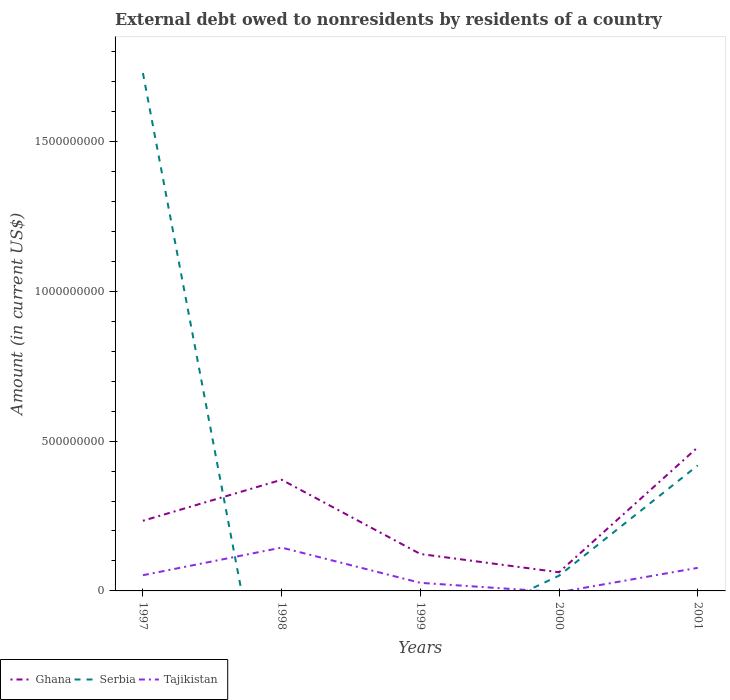How many different coloured lines are there?
Offer a very short reply. 3. Is the number of lines equal to the number of legend labels?
Ensure brevity in your answer.  No. Across all years, what is the maximum external debt owed by residents in Ghana?
Keep it short and to the point. 6.23e+07. What is the total external debt owed by residents in Serbia in the graph?
Keep it short and to the point. 1.31e+09. What is the difference between the highest and the second highest external debt owed by residents in Ghana?
Make the answer very short. 4.17e+08. What is the difference between the highest and the lowest external debt owed by residents in Tajikistan?
Your answer should be very brief. 2. Is the external debt owed by residents in Ghana strictly greater than the external debt owed by residents in Tajikistan over the years?
Your answer should be compact. No. How many years are there in the graph?
Your answer should be very brief. 5. What is the title of the graph?
Your response must be concise. External debt owed to nonresidents by residents of a country. Does "Burkina Faso" appear as one of the legend labels in the graph?
Give a very brief answer. No. What is the label or title of the Y-axis?
Your answer should be compact. Amount (in current US$). What is the Amount (in current US$) of Ghana in 1997?
Provide a short and direct response. 2.34e+08. What is the Amount (in current US$) of Serbia in 1997?
Provide a short and direct response. 1.73e+09. What is the Amount (in current US$) in Tajikistan in 1997?
Your answer should be very brief. 5.24e+07. What is the Amount (in current US$) in Ghana in 1998?
Offer a very short reply. 3.71e+08. What is the Amount (in current US$) in Tajikistan in 1998?
Ensure brevity in your answer.  1.45e+08. What is the Amount (in current US$) of Ghana in 1999?
Make the answer very short. 1.23e+08. What is the Amount (in current US$) in Tajikistan in 1999?
Offer a terse response. 2.70e+07. What is the Amount (in current US$) in Ghana in 2000?
Your answer should be compact. 6.23e+07. What is the Amount (in current US$) of Serbia in 2000?
Provide a succinct answer. 5.08e+07. What is the Amount (in current US$) of Tajikistan in 2000?
Your response must be concise. 0. What is the Amount (in current US$) in Ghana in 2001?
Provide a succinct answer. 4.79e+08. What is the Amount (in current US$) in Serbia in 2001?
Make the answer very short. 4.19e+08. What is the Amount (in current US$) in Tajikistan in 2001?
Provide a short and direct response. 7.70e+07. Across all years, what is the maximum Amount (in current US$) of Ghana?
Your answer should be compact. 4.79e+08. Across all years, what is the maximum Amount (in current US$) in Serbia?
Offer a very short reply. 1.73e+09. Across all years, what is the maximum Amount (in current US$) of Tajikistan?
Your response must be concise. 1.45e+08. Across all years, what is the minimum Amount (in current US$) in Ghana?
Give a very brief answer. 6.23e+07. Across all years, what is the minimum Amount (in current US$) in Serbia?
Give a very brief answer. 0. Across all years, what is the minimum Amount (in current US$) of Tajikistan?
Offer a very short reply. 0. What is the total Amount (in current US$) of Ghana in the graph?
Provide a succinct answer. 1.27e+09. What is the total Amount (in current US$) in Serbia in the graph?
Make the answer very short. 2.20e+09. What is the total Amount (in current US$) of Tajikistan in the graph?
Offer a terse response. 3.01e+08. What is the difference between the Amount (in current US$) of Ghana in 1997 and that in 1998?
Provide a short and direct response. -1.37e+08. What is the difference between the Amount (in current US$) in Tajikistan in 1997 and that in 1998?
Give a very brief answer. -9.22e+07. What is the difference between the Amount (in current US$) in Ghana in 1997 and that in 1999?
Your answer should be very brief. 1.11e+08. What is the difference between the Amount (in current US$) of Tajikistan in 1997 and that in 1999?
Keep it short and to the point. 2.54e+07. What is the difference between the Amount (in current US$) of Ghana in 1997 and that in 2000?
Provide a short and direct response. 1.72e+08. What is the difference between the Amount (in current US$) in Serbia in 1997 and that in 2000?
Ensure brevity in your answer.  1.68e+09. What is the difference between the Amount (in current US$) in Ghana in 1997 and that in 2001?
Keep it short and to the point. -2.45e+08. What is the difference between the Amount (in current US$) in Serbia in 1997 and that in 2001?
Give a very brief answer. 1.31e+09. What is the difference between the Amount (in current US$) in Tajikistan in 1997 and that in 2001?
Provide a short and direct response. -2.46e+07. What is the difference between the Amount (in current US$) of Ghana in 1998 and that in 1999?
Ensure brevity in your answer.  2.48e+08. What is the difference between the Amount (in current US$) in Tajikistan in 1998 and that in 1999?
Your answer should be compact. 1.18e+08. What is the difference between the Amount (in current US$) in Ghana in 1998 and that in 2000?
Provide a succinct answer. 3.09e+08. What is the difference between the Amount (in current US$) of Ghana in 1998 and that in 2001?
Keep it short and to the point. -1.08e+08. What is the difference between the Amount (in current US$) of Tajikistan in 1998 and that in 2001?
Your response must be concise. 6.76e+07. What is the difference between the Amount (in current US$) in Ghana in 1999 and that in 2000?
Ensure brevity in your answer.  6.10e+07. What is the difference between the Amount (in current US$) in Ghana in 1999 and that in 2001?
Your answer should be compact. -3.56e+08. What is the difference between the Amount (in current US$) in Tajikistan in 1999 and that in 2001?
Your answer should be very brief. -5.00e+07. What is the difference between the Amount (in current US$) in Ghana in 2000 and that in 2001?
Your answer should be very brief. -4.17e+08. What is the difference between the Amount (in current US$) of Serbia in 2000 and that in 2001?
Ensure brevity in your answer.  -3.68e+08. What is the difference between the Amount (in current US$) in Ghana in 1997 and the Amount (in current US$) in Tajikistan in 1998?
Make the answer very short. 8.95e+07. What is the difference between the Amount (in current US$) of Serbia in 1997 and the Amount (in current US$) of Tajikistan in 1998?
Your answer should be compact. 1.58e+09. What is the difference between the Amount (in current US$) in Ghana in 1997 and the Amount (in current US$) in Tajikistan in 1999?
Make the answer very short. 2.07e+08. What is the difference between the Amount (in current US$) in Serbia in 1997 and the Amount (in current US$) in Tajikistan in 1999?
Make the answer very short. 1.70e+09. What is the difference between the Amount (in current US$) of Ghana in 1997 and the Amount (in current US$) of Serbia in 2000?
Make the answer very short. 1.83e+08. What is the difference between the Amount (in current US$) of Ghana in 1997 and the Amount (in current US$) of Serbia in 2001?
Offer a very short reply. -1.85e+08. What is the difference between the Amount (in current US$) in Ghana in 1997 and the Amount (in current US$) in Tajikistan in 2001?
Make the answer very short. 1.57e+08. What is the difference between the Amount (in current US$) of Serbia in 1997 and the Amount (in current US$) of Tajikistan in 2001?
Offer a very short reply. 1.65e+09. What is the difference between the Amount (in current US$) of Ghana in 1998 and the Amount (in current US$) of Tajikistan in 1999?
Give a very brief answer. 3.44e+08. What is the difference between the Amount (in current US$) in Ghana in 1998 and the Amount (in current US$) in Serbia in 2000?
Make the answer very short. 3.20e+08. What is the difference between the Amount (in current US$) in Ghana in 1998 and the Amount (in current US$) in Serbia in 2001?
Offer a very short reply. -4.78e+07. What is the difference between the Amount (in current US$) of Ghana in 1998 and the Amount (in current US$) of Tajikistan in 2001?
Offer a very short reply. 2.94e+08. What is the difference between the Amount (in current US$) in Ghana in 1999 and the Amount (in current US$) in Serbia in 2000?
Your answer should be compact. 7.25e+07. What is the difference between the Amount (in current US$) of Ghana in 1999 and the Amount (in current US$) of Serbia in 2001?
Keep it short and to the point. -2.96e+08. What is the difference between the Amount (in current US$) in Ghana in 1999 and the Amount (in current US$) in Tajikistan in 2001?
Your answer should be compact. 4.63e+07. What is the difference between the Amount (in current US$) in Ghana in 2000 and the Amount (in current US$) in Serbia in 2001?
Provide a short and direct response. -3.57e+08. What is the difference between the Amount (in current US$) in Ghana in 2000 and the Amount (in current US$) in Tajikistan in 2001?
Your answer should be compact. -1.47e+07. What is the difference between the Amount (in current US$) in Serbia in 2000 and the Amount (in current US$) in Tajikistan in 2001?
Provide a short and direct response. -2.62e+07. What is the average Amount (in current US$) of Ghana per year?
Your answer should be compact. 2.54e+08. What is the average Amount (in current US$) in Serbia per year?
Give a very brief answer. 4.40e+08. What is the average Amount (in current US$) in Tajikistan per year?
Your answer should be compact. 6.02e+07. In the year 1997, what is the difference between the Amount (in current US$) in Ghana and Amount (in current US$) in Serbia?
Your answer should be very brief. -1.49e+09. In the year 1997, what is the difference between the Amount (in current US$) of Ghana and Amount (in current US$) of Tajikistan?
Offer a very short reply. 1.82e+08. In the year 1997, what is the difference between the Amount (in current US$) in Serbia and Amount (in current US$) in Tajikistan?
Offer a terse response. 1.68e+09. In the year 1998, what is the difference between the Amount (in current US$) in Ghana and Amount (in current US$) in Tajikistan?
Your response must be concise. 2.26e+08. In the year 1999, what is the difference between the Amount (in current US$) of Ghana and Amount (in current US$) of Tajikistan?
Keep it short and to the point. 9.63e+07. In the year 2000, what is the difference between the Amount (in current US$) in Ghana and Amount (in current US$) in Serbia?
Give a very brief answer. 1.15e+07. In the year 2001, what is the difference between the Amount (in current US$) of Ghana and Amount (in current US$) of Serbia?
Your response must be concise. 6.05e+07. In the year 2001, what is the difference between the Amount (in current US$) in Ghana and Amount (in current US$) in Tajikistan?
Your answer should be compact. 4.02e+08. In the year 2001, what is the difference between the Amount (in current US$) in Serbia and Amount (in current US$) in Tajikistan?
Ensure brevity in your answer.  3.42e+08. What is the ratio of the Amount (in current US$) in Ghana in 1997 to that in 1998?
Offer a terse response. 0.63. What is the ratio of the Amount (in current US$) in Tajikistan in 1997 to that in 1998?
Your answer should be very brief. 0.36. What is the ratio of the Amount (in current US$) of Ghana in 1997 to that in 1999?
Your answer should be compact. 1.9. What is the ratio of the Amount (in current US$) of Tajikistan in 1997 to that in 1999?
Provide a short and direct response. 1.94. What is the ratio of the Amount (in current US$) in Ghana in 1997 to that in 2000?
Ensure brevity in your answer.  3.76. What is the ratio of the Amount (in current US$) of Serbia in 1997 to that in 2000?
Your answer should be compact. 34.01. What is the ratio of the Amount (in current US$) in Ghana in 1997 to that in 2001?
Offer a terse response. 0.49. What is the ratio of the Amount (in current US$) in Serbia in 1997 to that in 2001?
Offer a terse response. 4.13. What is the ratio of the Amount (in current US$) in Tajikistan in 1997 to that in 2001?
Make the answer very short. 0.68. What is the ratio of the Amount (in current US$) in Ghana in 1998 to that in 1999?
Ensure brevity in your answer.  3.01. What is the ratio of the Amount (in current US$) of Tajikistan in 1998 to that in 1999?
Your answer should be very brief. 5.36. What is the ratio of the Amount (in current US$) in Ghana in 1998 to that in 2000?
Keep it short and to the point. 5.96. What is the ratio of the Amount (in current US$) in Ghana in 1998 to that in 2001?
Offer a terse response. 0.77. What is the ratio of the Amount (in current US$) in Tajikistan in 1998 to that in 2001?
Your response must be concise. 1.88. What is the ratio of the Amount (in current US$) in Ghana in 1999 to that in 2000?
Give a very brief answer. 1.98. What is the ratio of the Amount (in current US$) in Ghana in 1999 to that in 2001?
Your answer should be very brief. 0.26. What is the ratio of the Amount (in current US$) in Tajikistan in 1999 to that in 2001?
Give a very brief answer. 0.35. What is the ratio of the Amount (in current US$) of Ghana in 2000 to that in 2001?
Your response must be concise. 0.13. What is the ratio of the Amount (in current US$) of Serbia in 2000 to that in 2001?
Ensure brevity in your answer.  0.12. What is the difference between the highest and the second highest Amount (in current US$) of Ghana?
Ensure brevity in your answer.  1.08e+08. What is the difference between the highest and the second highest Amount (in current US$) of Serbia?
Your answer should be very brief. 1.31e+09. What is the difference between the highest and the second highest Amount (in current US$) of Tajikistan?
Make the answer very short. 6.76e+07. What is the difference between the highest and the lowest Amount (in current US$) of Ghana?
Your answer should be compact. 4.17e+08. What is the difference between the highest and the lowest Amount (in current US$) of Serbia?
Offer a very short reply. 1.73e+09. What is the difference between the highest and the lowest Amount (in current US$) of Tajikistan?
Ensure brevity in your answer.  1.45e+08. 